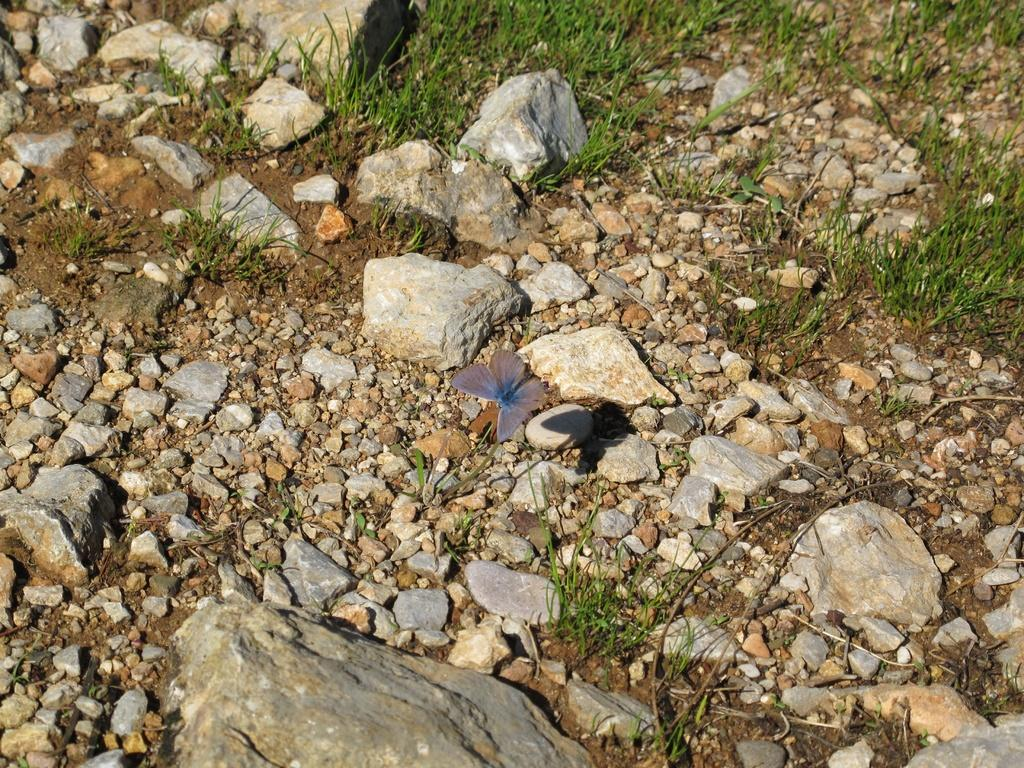What type of animal can be seen in the image? There is a butterfly in the image. What other objects or elements are present in the image? There are stones and grass on the ground in the image. What type of fog can be seen in the image? There is no fog present in the image; it features a butterfly, stones, and grass. What type of match is being used by the butterfly in the image? There is no match or any indication of a match in the image. 